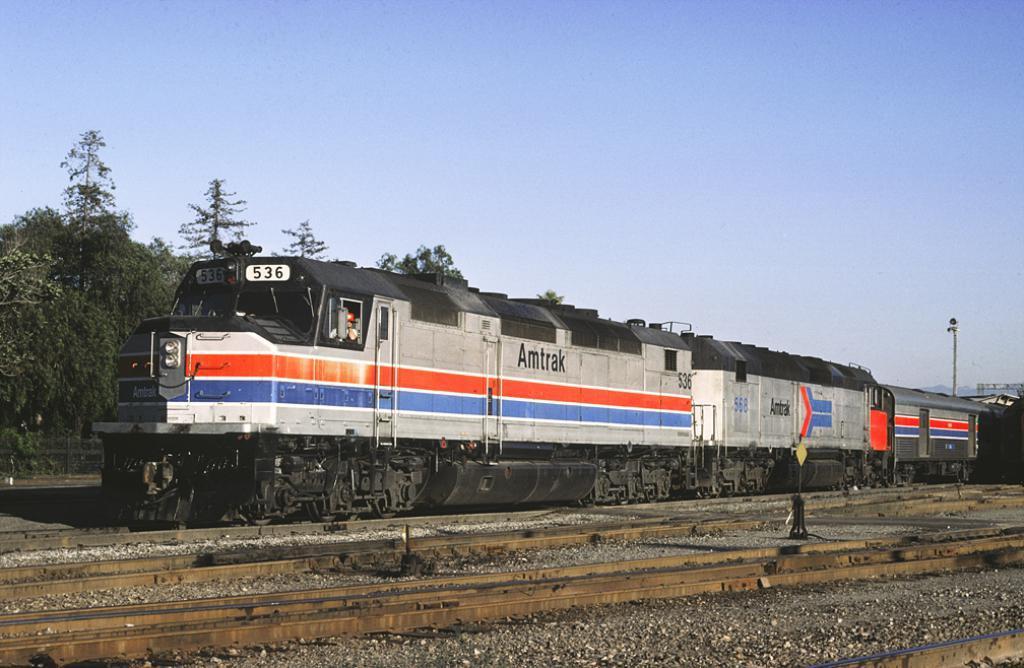Can you describe this image briefly? In this image I can see a train on the railway track. In the background, I can see the trees and the sky. 